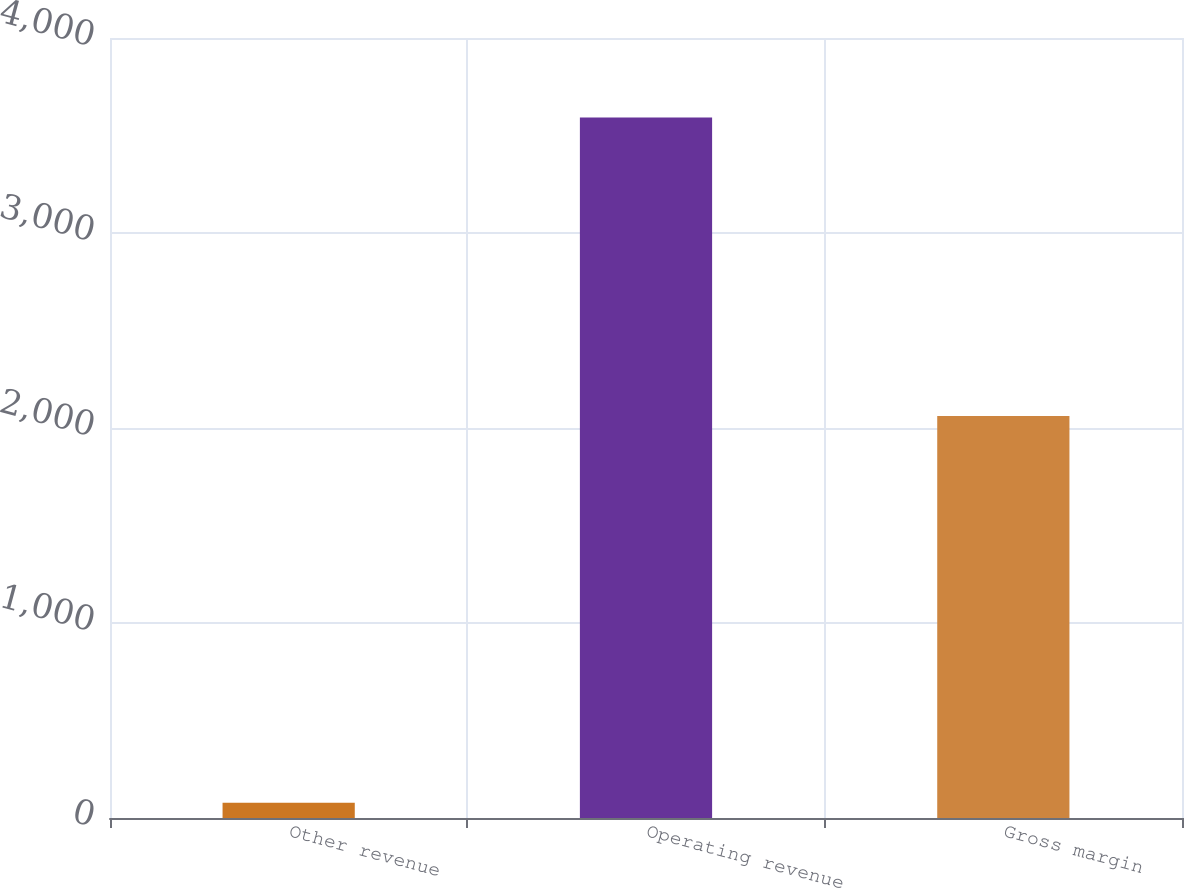Convert chart. <chart><loc_0><loc_0><loc_500><loc_500><bar_chart><fcel>Other revenue<fcel>Operating revenue<fcel>Gross margin<nl><fcel>78<fcel>3592<fcel>2062<nl></chart> 